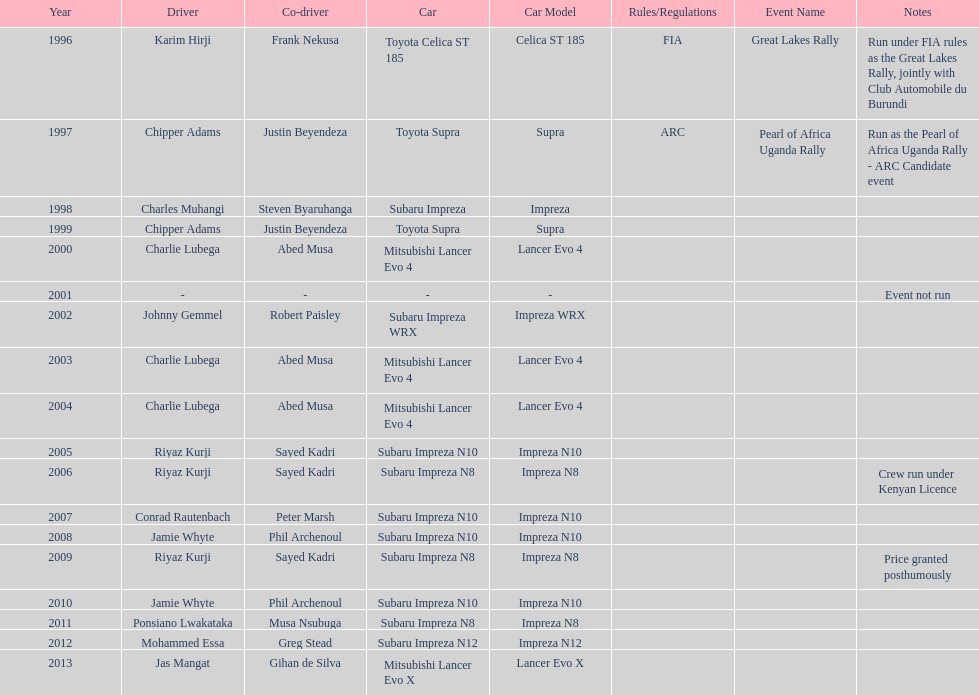Who is the only driver to have consecutive wins? Charlie Lubega. 